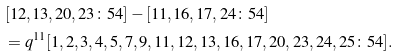<formula> <loc_0><loc_0><loc_500><loc_500>& [ 1 2 , 1 3 , 2 0 , 2 3 \colon 5 4 ] - [ 1 1 , 1 6 , 1 7 , 2 4 \colon 5 4 ] \\ & = q ^ { 1 1 } [ 1 , 2 , 3 , 4 , 5 , 7 , 9 , 1 1 , 1 2 , 1 3 , 1 6 , 1 7 , 2 0 , 2 3 , 2 4 , 2 5 \colon 5 4 ] .</formula> 